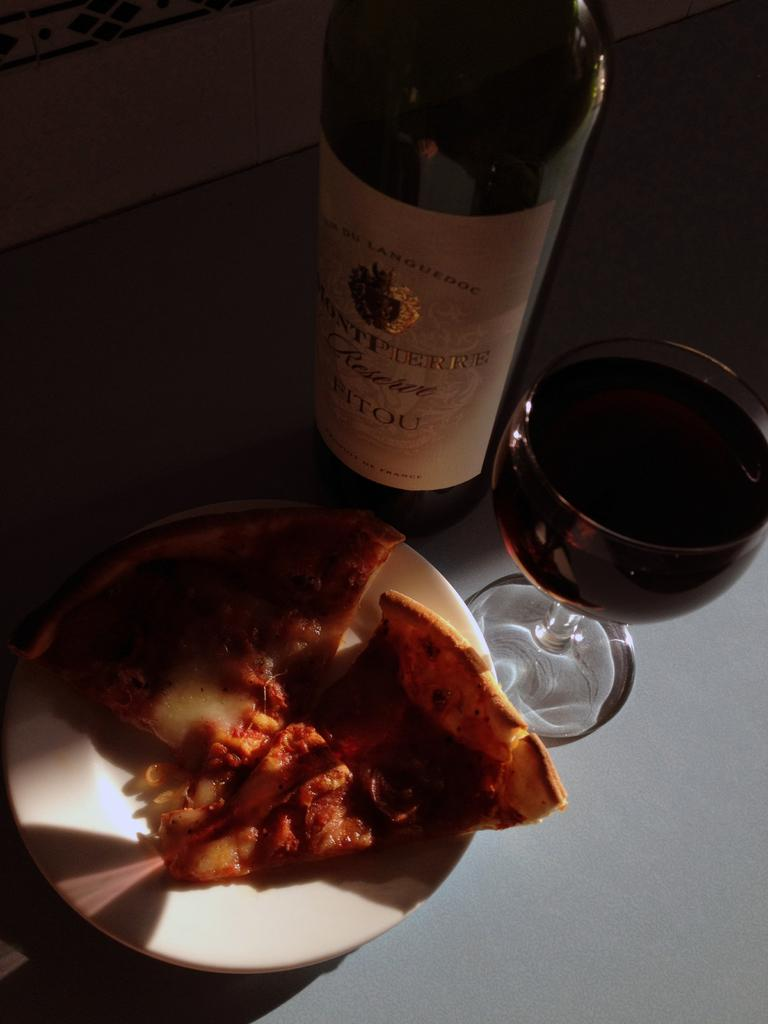<image>
Describe the image concisely. A red wine from France sits behind a wine glass and pizza slices. 